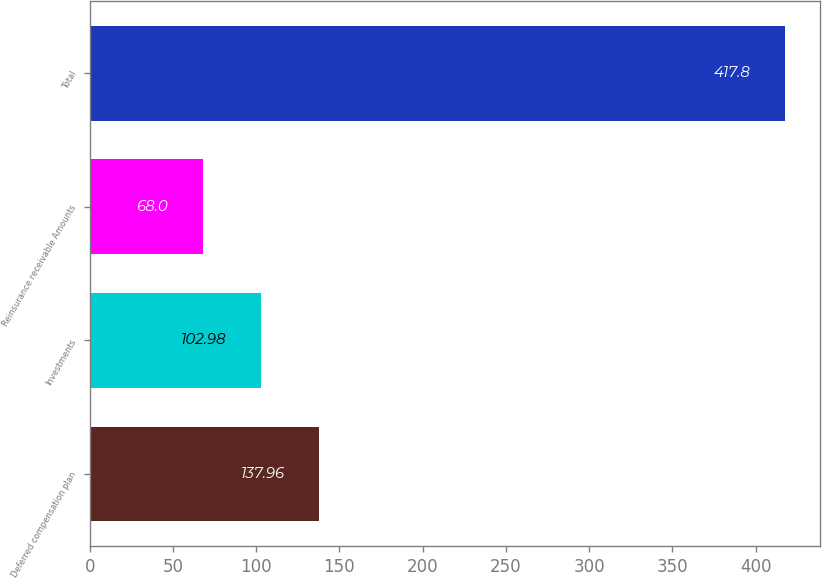<chart> <loc_0><loc_0><loc_500><loc_500><bar_chart><fcel>Deferred compensation plan<fcel>Investments<fcel>Reinsurance receivable Amounts<fcel>Total<nl><fcel>137.96<fcel>102.98<fcel>68<fcel>417.8<nl></chart> 